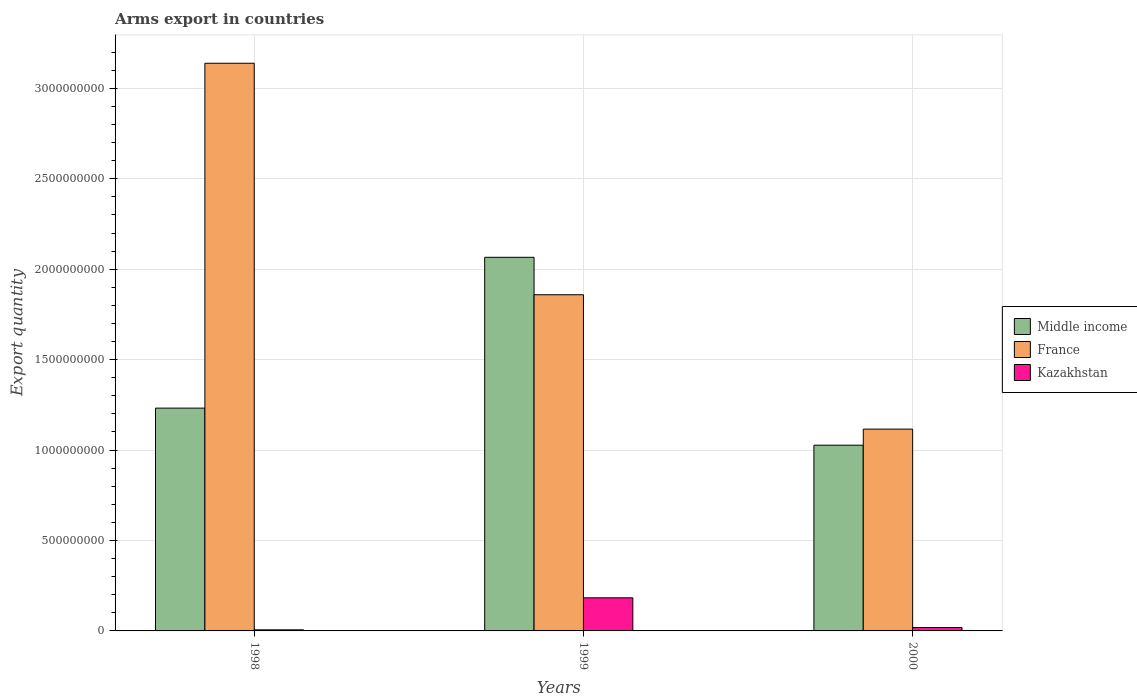How many bars are there on the 1st tick from the left?
Offer a very short reply. 3. In how many cases, is the number of bars for a given year not equal to the number of legend labels?
Ensure brevity in your answer.  0. What is the total arms export in Middle income in 1998?
Your response must be concise. 1.23e+09. Across all years, what is the maximum total arms export in Middle income?
Keep it short and to the point. 2.07e+09. Across all years, what is the minimum total arms export in France?
Provide a succinct answer. 1.12e+09. In which year was the total arms export in Kazakhstan maximum?
Your response must be concise. 1999. In which year was the total arms export in Middle income minimum?
Your answer should be very brief. 2000. What is the total total arms export in Middle income in the graph?
Your answer should be very brief. 4.32e+09. What is the difference between the total arms export in Kazakhstan in 1998 and that in 1999?
Your answer should be compact. -1.77e+08. What is the difference between the total arms export in Middle income in 2000 and the total arms export in Kazakhstan in 1998?
Provide a short and direct response. 1.02e+09. What is the average total arms export in Middle income per year?
Provide a succinct answer. 1.44e+09. In the year 1999, what is the difference between the total arms export in Kazakhstan and total arms export in France?
Provide a succinct answer. -1.68e+09. In how many years, is the total arms export in France greater than 2900000000?
Provide a succinct answer. 1. What is the ratio of the total arms export in France in 1998 to that in 2000?
Keep it short and to the point. 2.81. Is the total arms export in Kazakhstan in 1998 less than that in 2000?
Provide a succinct answer. Yes. What is the difference between the highest and the second highest total arms export in Middle income?
Your answer should be compact. 8.34e+08. What is the difference between the highest and the lowest total arms export in Kazakhstan?
Offer a terse response. 1.77e+08. What does the 3rd bar from the left in 1999 represents?
Your answer should be compact. Kazakhstan. What does the 3rd bar from the right in 1998 represents?
Ensure brevity in your answer.  Middle income. How many bars are there?
Keep it short and to the point. 9. Does the graph contain grids?
Keep it short and to the point. Yes. How many legend labels are there?
Give a very brief answer. 3. How are the legend labels stacked?
Keep it short and to the point. Vertical. What is the title of the graph?
Your response must be concise. Arms export in countries. What is the label or title of the X-axis?
Ensure brevity in your answer.  Years. What is the label or title of the Y-axis?
Give a very brief answer. Export quantity. What is the Export quantity in Middle income in 1998?
Your response must be concise. 1.23e+09. What is the Export quantity in France in 1998?
Your response must be concise. 3.14e+09. What is the Export quantity in Kazakhstan in 1998?
Offer a very short reply. 6.00e+06. What is the Export quantity of Middle income in 1999?
Your answer should be very brief. 2.07e+09. What is the Export quantity of France in 1999?
Your answer should be compact. 1.86e+09. What is the Export quantity of Kazakhstan in 1999?
Make the answer very short. 1.83e+08. What is the Export quantity in Middle income in 2000?
Your answer should be compact. 1.03e+09. What is the Export quantity in France in 2000?
Ensure brevity in your answer.  1.12e+09. What is the Export quantity in Kazakhstan in 2000?
Give a very brief answer. 1.90e+07. Across all years, what is the maximum Export quantity in Middle income?
Provide a succinct answer. 2.07e+09. Across all years, what is the maximum Export quantity of France?
Provide a short and direct response. 3.14e+09. Across all years, what is the maximum Export quantity of Kazakhstan?
Ensure brevity in your answer.  1.83e+08. Across all years, what is the minimum Export quantity in Middle income?
Give a very brief answer. 1.03e+09. Across all years, what is the minimum Export quantity in France?
Your response must be concise. 1.12e+09. Across all years, what is the minimum Export quantity in Kazakhstan?
Ensure brevity in your answer.  6.00e+06. What is the total Export quantity in Middle income in the graph?
Your answer should be very brief. 4.32e+09. What is the total Export quantity in France in the graph?
Offer a terse response. 6.11e+09. What is the total Export quantity of Kazakhstan in the graph?
Give a very brief answer. 2.08e+08. What is the difference between the Export quantity in Middle income in 1998 and that in 1999?
Your answer should be compact. -8.34e+08. What is the difference between the Export quantity in France in 1998 and that in 1999?
Offer a terse response. 1.28e+09. What is the difference between the Export quantity in Kazakhstan in 1998 and that in 1999?
Ensure brevity in your answer.  -1.77e+08. What is the difference between the Export quantity in Middle income in 1998 and that in 2000?
Ensure brevity in your answer.  2.05e+08. What is the difference between the Export quantity in France in 1998 and that in 2000?
Your response must be concise. 2.02e+09. What is the difference between the Export quantity in Kazakhstan in 1998 and that in 2000?
Your answer should be very brief. -1.30e+07. What is the difference between the Export quantity in Middle income in 1999 and that in 2000?
Provide a succinct answer. 1.04e+09. What is the difference between the Export quantity of France in 1999 and that in 2000?
Offer a terse response. 7.43e+08. What is the difference between the Export quantity of Kazakhstan in 1999 and that in 2000?
Make the answer very short. 1.64e+08. What is the difference between the Export quantity of Middle income in 1998 and the Export quantity of France in 1999?
Provide a succinct answer. -6.27e+08. What is the difference between the Export quantity in Middle income in 1998 and the Export quantity in Kazakhstan in 1999?
Make the answer very short. 1.05e+09. What is the difference between the Export quantity of France in 1998 and the Export quantity of Kazakhstan in 1999?
Your answer should be very brief. 2.96e+09. What is the difference between the Export quantity of Middle income in 1998 and the Export quantity of France in 2000?
Your answer should be very brief. 1.16e+08. What is the difference between the Export quantity in Middle income in 1998 and the Export quantity in Kazakhstan in 2000?
Provide a short and direct response. 1.21e+09. What is the difference between the Export quantity in France in 1998 and the Export quantity in Kazakhstan in 2000?
Offer a very short reply. 3.12e+09. What is the difference between the Export quantity of Middle income in 1999 and the Export quantity of France in 2000?
Keep it short and to the point. 9.50e+08. What is the difference between the Export quantity of Middle income in 1999 and the Export quantity of Kazakhstan in 2000?
Make the answer very short. 2.05e+09. What is the difference between the Export quantity in France in 1999 and the Export quantity in Kazakhstan in 2000?
Offer a very short reply. 1.84e+09. What is the average Export quantity in Middle income per year?
Provide a succinct answer. 1.44e+09. What is the average Export quantity in France per year?
Offer a very short reply. 2.04e+09. What is the average Export quantity of Kazakhstan per year?
Offer a very short reply. 6.93e+07. In the year 1998, what is the difference between the Export quantity of Middle income and Export quantity of France?
Offer a very short reply. -1.91e+09. In the year 1998, what is the difference between the Export quantity in Middle income and Export quantity in Kazakhstan?
Offer a very short reply. 1.23e+09. In the year 1998, what is the difference between the Export quantity in France and Export quantity in Kazakhstan?
Make the answer very short. 3.13e+09. In the year 1999, what is the difference between the Export quantity in Middle income and Export quantity in France?
Keep it short and to the point. 2.07e+08. In the year 1999, what is the difference between the Export quantity of Middle income and Export quantity of Kazakhstan?
Your answer should be very brief. 1.88e+09. In the year 1999, what is the difference between the Export quantity in France and Export quantity in Kazakhstan?
Provide a succinct answer. 1.68e+09. In the year 2000, what is the difference between the Export quantity in Middle income and Export quantity in France?
Your response must be concise. -8.90e+07. In the year 2000, what is the difference between the Export quantity of Middle income and Export quantity of Kazakhstan?
Offer a very short reply. 1.01e+09. In the year 2000, what is the difference between the Export quantity in France and Export quantity in Kazakhstan?
Provide a succinct answer. 1.10e+09. What is the ratio of the Export quantity in Middle income in 1998 to that in 1999?
Provide a succinct answer. 0.6. What is the ratio of the Export quantity in France in 1998 to that in 1999?
Your answer should be compact. 1.69. What is the ratio of the Export quantity of Kazakhstan in 1998 to that in 1999?
Keep it short and to the point. 0.03. What is the ratio of the Export quantity in Middle income in 1998 to that in 2000?
Provide a short and direct response. 1.2. What is the ratio of the Export quantity of France in 1998 to that in 2000?
Offer a terse response. 2.81. What is the ratio of the Export quantity of Kazakhstan in 1998 to that in 2000?
Make the answer very short. 0.32. What is the ratio of the Export quantity of Middle income in 1999 to that in 2000?
Your answer should be very brief. 2.01. What is the ratio of the Export quantity of France in 1999 to that in 2000?
Offer a very short reply. 1.67. What is the ratio of the Export quantity of Kazakhstan in 1999 to that in 2000?
Give a very brief answer. 9.63. What is the difference between the highest and the second highest Export quantity in Middle income?
Give a very brief answer. 8.34e+08. What is the difference between the highest and the second highest Export quantity in France?
Give a very brief answer. 1.28e+09. What is the difference between the highest and the second highest Export quantity of Kazakhstan?
Offer a very short reply. 1.64e+08. What is the difference between the highest and the lowest Export quantity in Middle income?
Keep it short and to the point. 1.04e+09. What is the difference between the highest and the lowest Export quantity of France?
Offer a terse response. 2.02e+09. What is the difference between the highest and the lowest Export quantity in Kazakhstan?
Provide a short and direct response. 1.77e+08. 